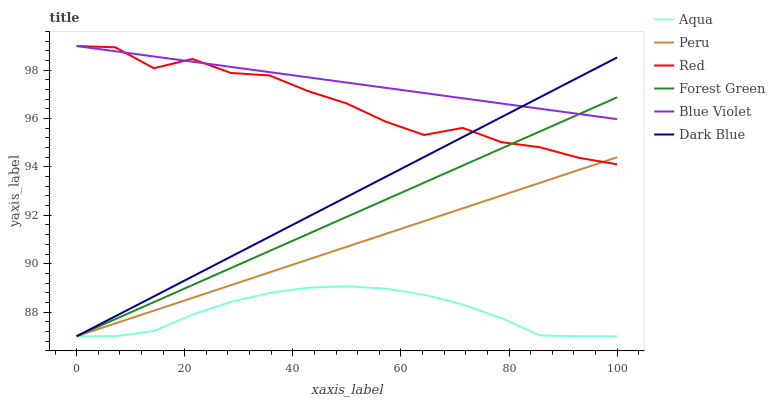Does Aqua have the minimum area under the curve?
Answer yes or no. Yes. Does Blue Violet have the maximum area under the curve?
Answer yes or no. Yes. Does Dark Blue have the minimum area under the curve?
Answer yes or no. No. Does Dark Blue have the maximum area under the curve?
Answer yes or no. No. Is Peru the smoothest?
Answer yes or no. Yes. Is Red the roughest?
Answer yes or no. Yes. Is Dark Blue the smoothest?
Answer yes or no. No. Is Dark Blue the roughest?
Answer yes or no. No. Does Aqua have the lowest value?
Answer yes or no. Yes. Does Red have the lowest value?
Answer yes or no. No. Does Blue Violet have the highest value?
Answer yes or no. Yes. Does Dark Blue have the highest value?
Answer yes or no. No. Is Aqua less than Blue Violet?
Answer yes or no. Yes. Is Blue Violet greater than Aqua?
Answer yes or no. Yes. Does Peru intersect Forest Green?
Answer yes or no. Yes. Is Peru less than Forest Green?
Answer yes or no. No. Is Peru greater than Forest Green?
Answer yes or no. No. Does Aqua intersect Blue Violet?
Answer yes or no. No. 